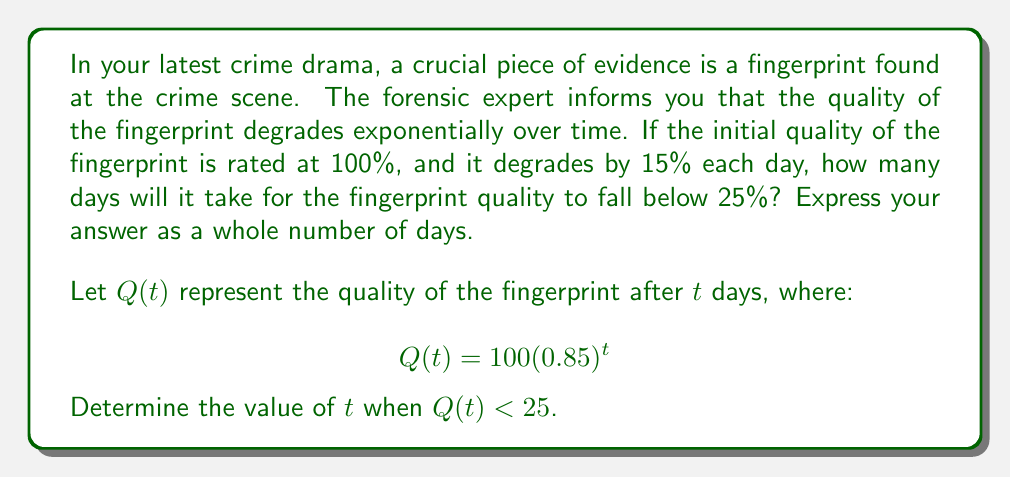Help me with this question. To solve this problem, we need to use the exponential decay function and solve an inequality. Let's break it down step by step:

1) We start with the equation: $Q(t) = 100(0.85)^t$

2) We want to find when $Q(t) < 25$, so we set up the inequality:
   
   $100(0.85)^t < 25$

3) Divide both sides by 100:
   
   $(0.85)^t < 0.25$

4) Take the natural log of both sides. Remember, when we take the log of an inequality, the direction of the inequality can change if the base is less than 1. In this case, 0.85 is less than 1, so the inequality will flip:
   
   $\ln(0.85)^t > \ln(0.25)$

5) Use the logarithm property $\ln(a^b) = b\ln(a)$:
   
   $t\ln(0.85) > \ln(0.25)$

6) Divide both sides by $\ln(0.85)$ (note that $\ln(0.85)$ is negative, so the inequality flips again):
   
   $t < \frac{\ln(0.25)}{\ln(0.85)}$

7) Calculate this value:
   
   $t < \frac{\ln(0.25)}{\ln(0.85)} \approx 8.9657$

8) Since we need the number of whole days, we round up to the next integer.
Answer: 9 days 